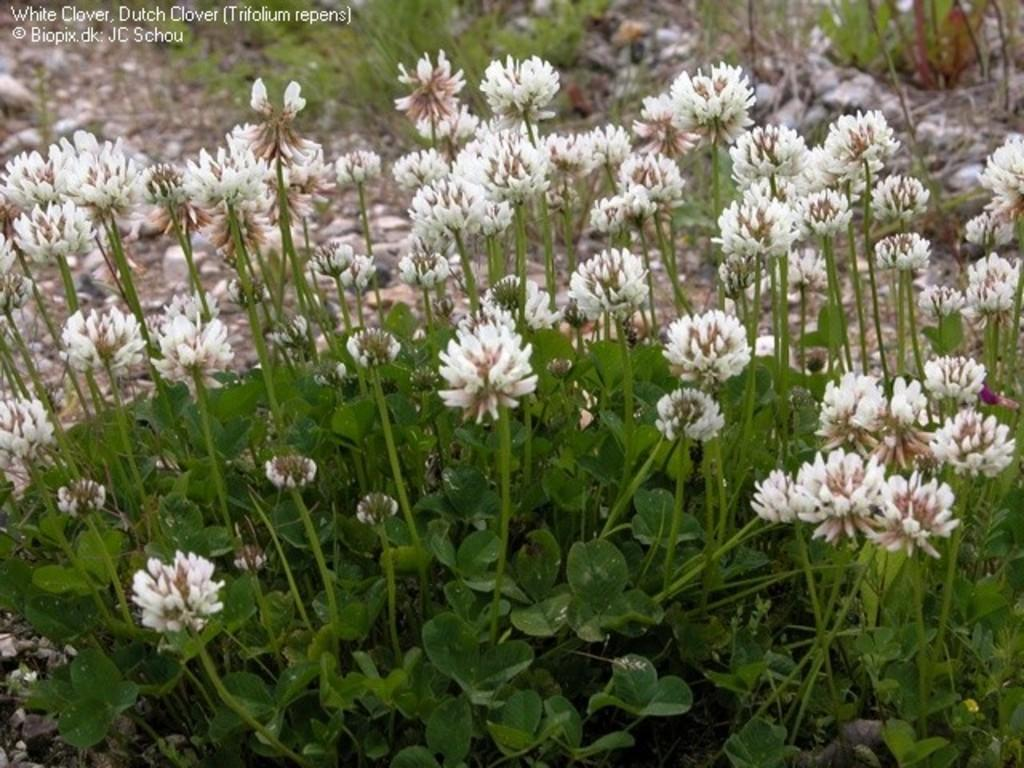What type of living organisms can be seen in the image? Plants and flowers are visible in the image. What is the surface on which the plants and flowers are growing? The ground is visible in the image. What type of vegetation is present in the image? There is grass in the image. Is there any text present in the image? Yes, there is some text in the top left corner of the image. What type of food is being prepared in the image? There is no food preparation visible in the image; it features plants, flowers, and text. Can you tell me how many oceans are depicted in the image? There are no oceans present in the image. 